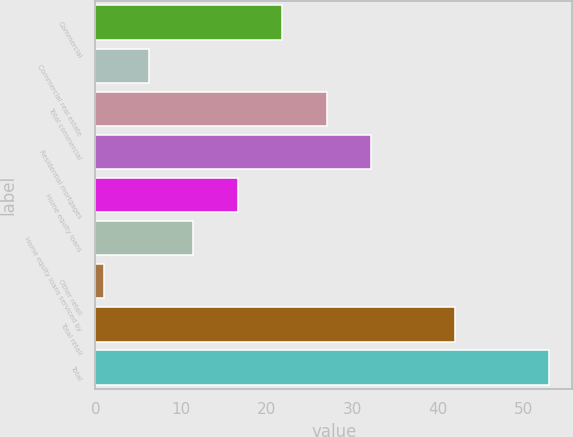<chart> <loc_0><loc_0><loc_500><loc_500><bar_chart><fcel>Commercial<fcel>Commercial real estate<fcel>Total commercial<fcel>Residential mortgages<fcel>Home equity loans<fcel>Home equity loans serviced by<fcel>Other retail<fcel>Total retail<fcel>Total<nl><fcel>21.8<fcel>6.2<fcel>27<fcel>32.2<fcel>16.6<fcel>11.4<fcel>1<fcel>42<fcel>53<nl></chart> 